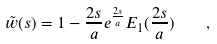Convert formula to latex. <formula><loc_0><loc_0><loc_500><loc_500>\tilde { w } ( s ) = 1 - \frac { 2 s } { a } e ^ { \frac { 2 s } { a } } E _ { 1 } ( \frac { 2 s } { a } ) \quad ,</formula> 